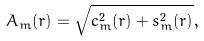<formula> <loc_0><loc_0><loc_500><loc_500>A _ { m } ( r ) = \sqrt { c _ { m } ^ { 2 } ( r ) + s _ { m } ^ { 2 } ( r ) } ,</formula> 